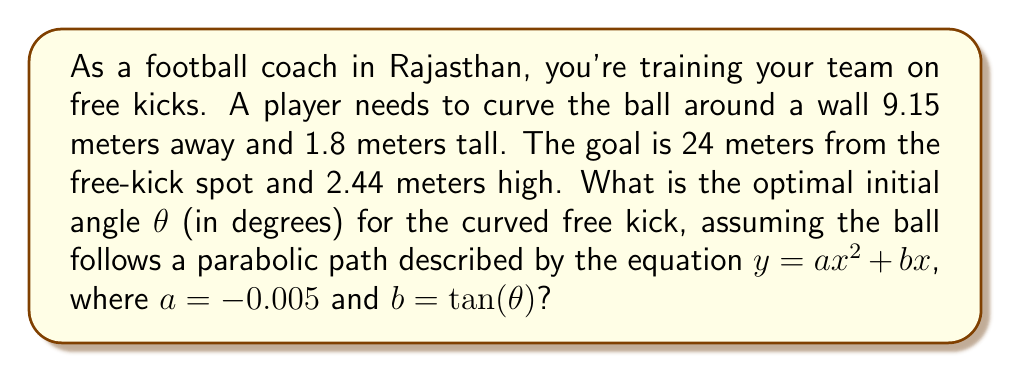Show me your answer to this math problem. Let's approach this step-by-step:

1) The parabolic equation of the ball's path is $y = -0.005x^2 + (\tan θ)x$

2) We need to ensure the ball clears the wall. At $x = 9.15$ (wall distance), $y$ should be greater than 1.8 (wall height):

   $1.8 < -0.005(9.15)^2 + (\tan θ)(9.15)$

3) The ball should enter the goal at $x = 24$. At this point, $y$ should be less than or equal to 2.44 (goal height):

   $-0.005(24)^2 + (\tan θ)(24) \leq 2.44$

4) From step 2:
   $1.8 < -0.419 + 9.15\tan θ$
   $2.219 < 9.15\tan θ$
   $\tan θ > 0.2425$

5) From step 3:
   $-2.88 + 24\tan θ \leq 2.44$
   $24\tan θ \leq 5.32$
   $\tan θ \leq 0.2217$

6) For the optimal angle, we want the ball to just clear the wall and enter at the top of the goal. So we solve:

   $\tan θ = 0.2217$

7) Taking the inverse tangent:

   $θ = \arctan(0.2217) ≈ 12.48°$
Answer: $12.48°$ 